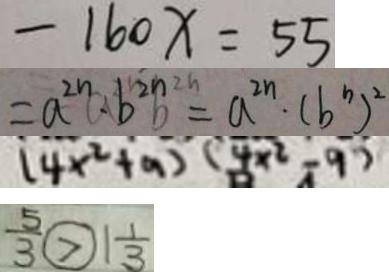<formula> <loc_0><loc_0><loc_500><loc_500>- 1 6 0 x = 5 5 
 = a ^ { 2 n } \cdot b ^ { 2 n } b = a ^ { 2 n } \cdot ( b ^ { n } ) ^ { 2 } 
 ( 4 x ^ { 2 } + a ) ( 4 x ^ { 2 } - 9 ) 
 \frac { 5 } { 3 } > 1 \frac { 1 } { 3 }</formula> 